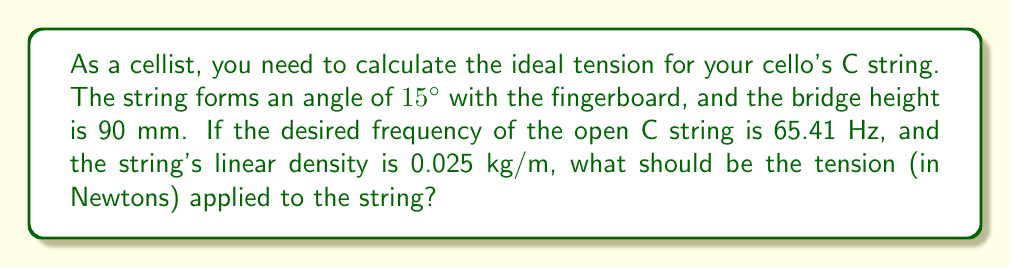What is the answer to this math problem? Let's approach this step-by-step:

1) First, we need to use the equation for the frequency of a vibrating string:

   $$f = \frac{1}{2L}\sqrt{\frac{T}{\mu}}$$

   Where:
   $f$ = frequency (65.41 Hz)
   $L$ = length of the string
   $T$ = tension (what we're solving for)
   $\mu$ = linear density (0.025 kg/m)

2) We don't know the length of the string, but we can calculate it using trigonometry:

   $$\tan 15° = \frac{90 \text{ mm}}{L}$$

3) Solving for $L$:

   $$L = \frac{90 \text{ mm}}{\tan 15°} \approx 337.1 \text{ mm} = 0.3371 \text{ m}$$

4) Now we can rearrange our frequency equation to solve for $T$:

   $$T = 4L^2f^2\mu$$

5) Plugging in our values:

   $$T = 4 \times (0.3371 \text{ m})^2 \times (65.41 \text{ Hz})^2 \times 0.025 \text{ kg/m}$$

6) Calculating:

   $$T \approx 147.3 \text{ N}$$

Therefore, the ideal tension for the C string is approximately 147.3 Newtons.
Answer: 147.3 N 